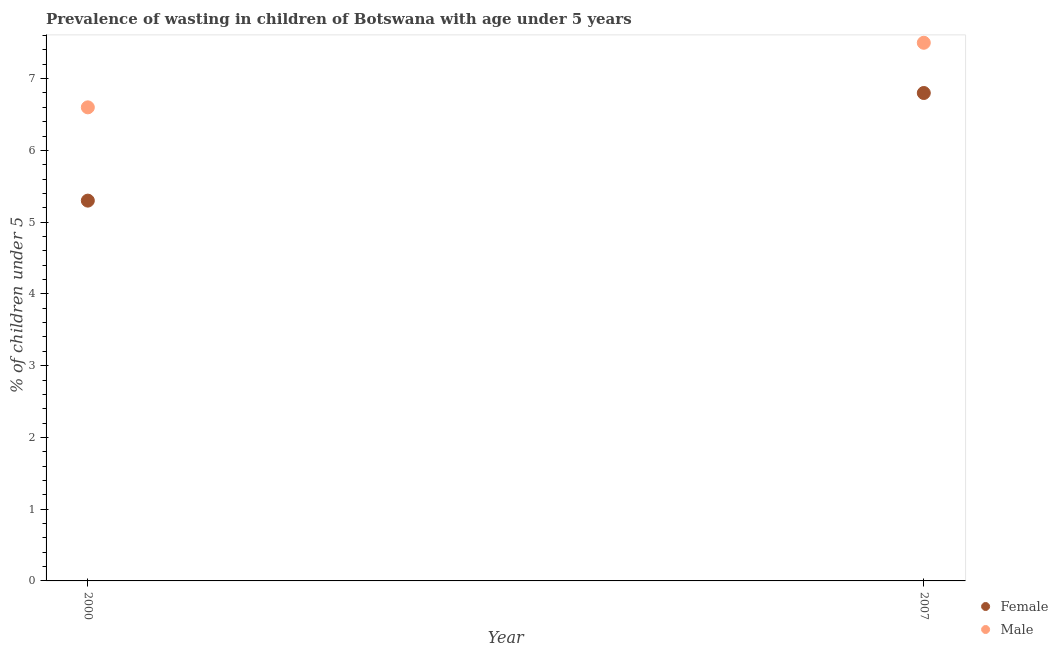How many different coloured dotlines are there?
Keep it short and to the point. 2. Is the number of dotlines equal to the number of legend labels?
Provide a succinct answer. Yes. Across all years, what is the maximum percentage of undernourished female children?
Offer a very short reply. 6.8. Across all years, what is the minimum percentage of undernourished female children?
Make the answer very short. 5.3. In which year was the percentage of undernourished male children maximum?
Provide a succinct answer. 2007. In which year was the percentage of undernourished female children minimum?
Keep it short and to the point. 2000. What is the total percentage of undernourished male children in the graph?
Offer a very short reply. 14.1. What is the difference between the percentage of undernourished male children in 2000 and that in 2007?
Ensure brevity in your answer.  -0.9. What is the difference between the percentage of undernourished male children in 2007 and the percentage of undernourished female children in 2000?
Your response must be concise. 2.2. What is the average percentage of undernourished female children per year?
Give a very brief answer. 6.05. In the year 2000, what is the difference between the percentage of undernourished male children and percentage of undernourished female children?
Provide a short and direct response. 1.3. What is the ratio of the percentage of undernourished male children in 2000 to that in 2007?
Provide a succinct answer. 0.88. Is the percentage of undernourished male children in 2000 less than that in 2007?
Provide a short and direct response. Yes. In how many years, is the percentage of undernourished female children greater than the average percentage of undernourished female children taken over all years?
Provide a short and direct response. 1. Does the percentage of undernourished female children monotonically increase over the years?
Your answer should be compact. Yes. Is the percentage of undernourished male children strictly greater than the percentage of undernourished female children over the years?
Your response must be concise. Yes. Is the percentage of undernourished male children strictly less than the percentage of undernourished female children over the years?
Your response must be concise. No. How many dotlines are there?
Make the answer very short. 2. What is the difference between two consecutive major ticks on the Y-axis?
Your answer should be compact. 1. Does the graph contain grids?
Offer a terse response. No. How many legend labels are there?
Offer a very short reply. 2. How are the legend labels stacked?
Offer a terse response. Vertical. What is the title of the graph?
Your answer should be very brief. Prevalence of wasting in children of Botswana with age under 5 years. Does "Research and Development" appear as one of the legend labels in the graph?
Offer a terse response. No. What is the label or title of the Y-axis?
Your answer should be very brief.  % of children under 5. What is the  % of children under 5 in Female in 2000?
Give a very brief answer. 5.3. What is the  % of children under 5 in Male in 2000?
Your answer should be very brief. 6.6. What is the  % of children under 5 in Female in 2007?
Keep it short and to the point. 6.8. Across all years, what is the maximum  % of children under 5 of Female?
Offer a terse response. 6.8. Across all years, what is the maximum  % of children under 5 of Male?
Make the answer very short. 7.5. Across all years, what is the minimum  % of children under 5 of Female?
Provide a short and direct response. 5.3. Across all years, what is the minimum  % of children under 5 of Male?
Your answer should be compact. 6.6. What is the average  % of children under 5 of Female per year?
Offer a terse response. 6.05. What is the average  % of children under 5 of Male per year?
Your answer should be compact. 7.05. In the year 2000, what is the difference between the  % of children under 5 in Female and  % of children under 5 in Male?
Your answer should be compact. -1.3. What is the ratio of the  % of children under 5 in Female in 2000 to that in 2007?
Provide a short and direct response. 0.78. What is the ratio of the  % of children under 5 in Male in 2000 to that in 2007?
Your answer should be compact. 0.88. What is the difference between the highest and the second highest  % of children under 5 in Female?
Offer a very short reply. 1.5. What is the difference between the highest and the lowest  % of children under 5 in Female?
Keep it short and to the point. 1.5. What is the difference between the highest and the lowest  % of children under 5 of Male?
Your response must be concise. 0.9. 